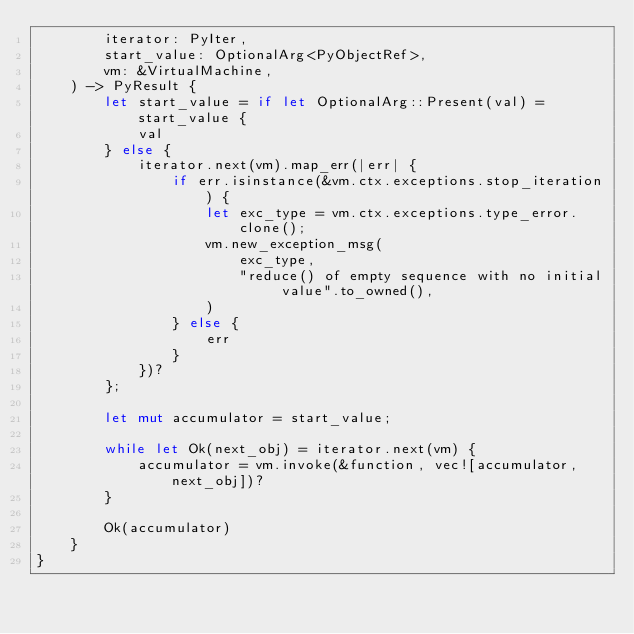<code> <loc_0><loc_0><loc_500><loc_500><_Rust_>        iterator: PyIter,
        start_value: OptionalArg<PyObjectRef>,
        vm: &VirtualMachine,
    ) -> PyResult {
        let start_value = if let OptionalArg::Present(val) = start_value {
            val
        } else {
            iterator.next(vm).map_err(|err| {
                if err.isinstance(&vm.ctx.exceptions.stop_iteration) {
                    let exc_type = vm.ctx.exceptions.type_error.clone();
                    vm.new_exception_msg(
                        exc_type,
                        "reduce() of empty sequence with no initial value".to_owned(),
                    )
                } else {
                    err
                }
            })?
        };

        let mut accumulator = start_value;

        while let Ok(next_obj) = iterator.next(vm) {
            accumulator = vm.invoke(&function, vec![accumulator, next_obj])?
        }

        Ok(accumulator)
    }
}
</code> 